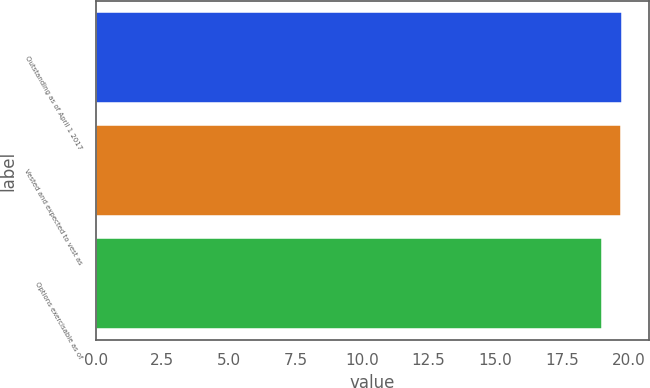Convert chart to OTSL. <chart><loc_0><loc_0><loc_500><loc_500><bar_chart><fcel>Outstanding as of April 1 2017<fcel>Vested and expected to vest as<fcel>Options exercisable as of<nl><fcel>19.78<fcel>19.71<fcel>19<nl></chart> 